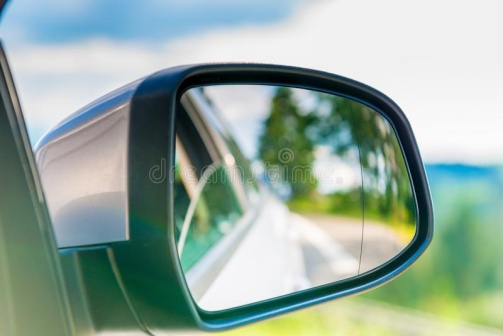What do you think is going on in this snapshot? The image captures a moment from inside a car, focusing on the car's side mirror. The mirror, black in color, is attached to the car's silver door and reflects a picturesque view of the surroundings. The reflection reveals a winding road, disappearing into the distance, bordered by lush green trees on either side. Above, the sky is a clear blue, dotted with a few clouds. The background of the image is blurred, drawing attention to the mirror and its reflection. The image does not contain any discernible text. The relative positions of the objects suggest that the car is positioned on the road, ready to embark on a journey amidst nature. 